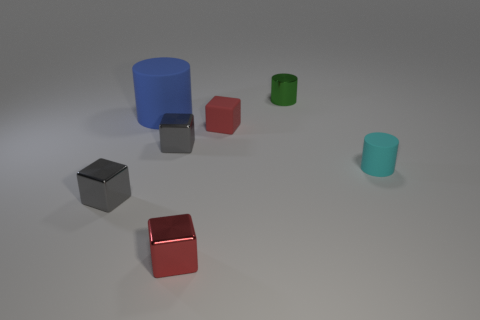Add 2 red cubes. How many objects exist? 9 Subtract all cylinders. How many objects are left? 4 Subtract 2 red blocks. How many objects are left? 5 Subtract all big rubber things. Subtract all tiny red blocks. How many objects are left? 4 Add 6 small shiny cylinders. How many small shiny cylinders are left? 7 Add 3 gray metallic things. How many gray metallic things exist? 5 